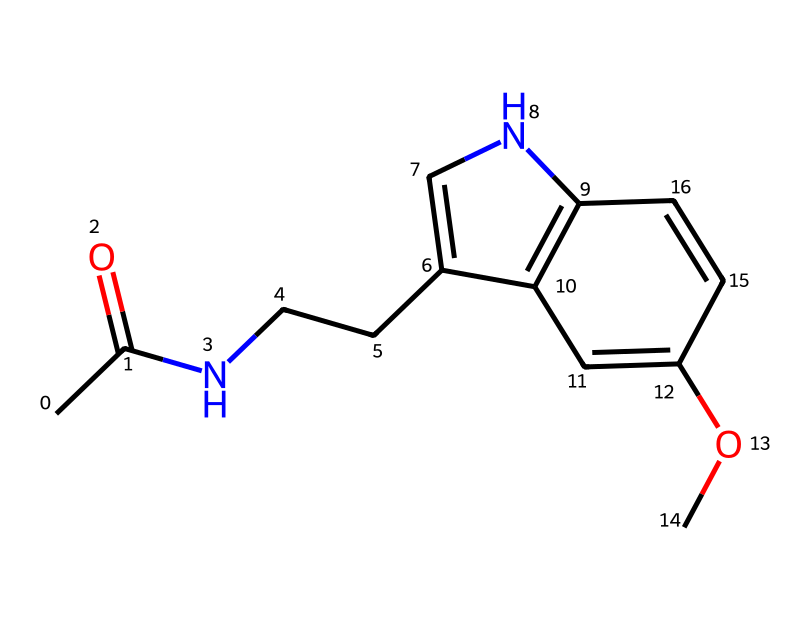How many rings are present in the structure of melatonin? The structure of melatonin includes a bicyclic structure, meaning it has two rings (one is a six-membered aromatic ring and the other is a five-membered ring). Hence, upon examining the structure, we can identify these two rings easily.
Answer: 2 What is the core functional group of melatonin? Melatonin contains an amide functional group, signified by the -C(=O)N- part of the structure. This is the core functional group that determines several properties of the compound.
Answer: amide How many carbon atoms are in melatonin? By counting the carbon atoms in the structure, we find a total of 11 carbons present in different parts of the molecule. Each carbon atom is shown in the skeletal structure, providing a clear view.
Answer: 11 Which atoms in melatonin indicate the presence of a nitrogen atom? There is one nitrogen atom in the structure of melatonin, which is specifically indicated by the presence of "N" in the SMILES representation. This nitrogen is connected to two different parts of the molecule, giving it specific chemical properties.
Answer: 1 How does the -OCH3 group in melatonin affect its properties? The -OCH3 (methoxy) group attached to the aromatic ring can influence the compound's polarity and solubility, enhancing its interaction with biological systems. Moreover, methoxy groups often modify the electron density of the aromatic system, impacting its reactivity and interactions.
Answer: enhances polarity How many hydrogen atoms are in melatonin? To determine the number of hydrogen atoms, we follow the connectivity and assume that each carbon forms four bonds. After counting based on the satisfaction of carbon's tetravalency, we find there are 12 hydrogen atoms in total in the molecule.
Answer: 12 What is the main chemical classification of melatonin? Melatonin is classified as an indoleamine based on its core structure, which consists of an indole ring fused to an amine group. This classification is fundamental for understanding its biological significance.
Answer: indoleamine 